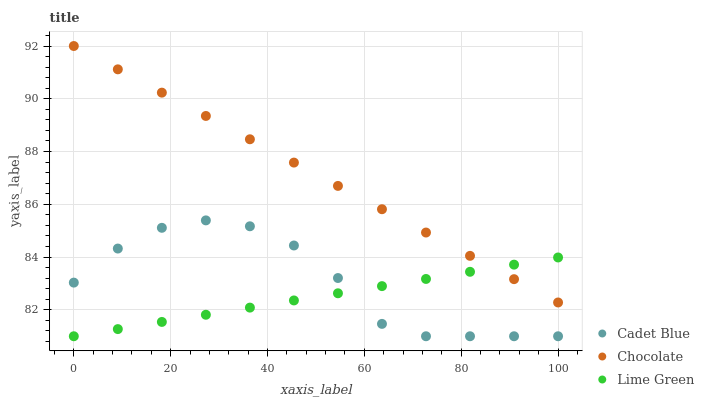Does Lime Green have the minimum area under the curve?
Answer yes or no. Yes. Does Chocolate have the maximum area under the curve?
Answer yes or no. Yes. Does Chocolate have the minimum area under the curve?
Answer yes or no. No. Does Lime Green have the maximum area under the curve?
Answer yes or no. No. Is Lime Green the smoothest?
Answer yes or no. Yes. Is Cadet Blue the roughest?
Answer yes or no. Yes. Is Chocolate the smoothest?
Answer yes or no. No. Is Chocolate the roughest?
Answer yes or no. No. Does Cadet Blue have the lowest value?
Answer yes or no. Yes. Does Chocolate have the lowest value?
Answer yes or no. No. Does Chocolate have the highest value?
Answer yes or no. Yes. Does Lime Green have the highest value?
Answer yes or no. No. Is Cadet Blue less than Chocolate?
Answer yes or no. Yes. Is Chocolate greater than Cadet Blue?
Answer yes or no. Yes. Does Cadet Blue intersect Lime Green?
Answer yes or no. Yes. Is Cadet Blue less than Lime Green?
Answer yes or no. No. Is Cadet Blue greater than Lime Green?
Answer yes or no. No. Does Cadet Blue intersect Chocolate?
Answer yes or no. No. 